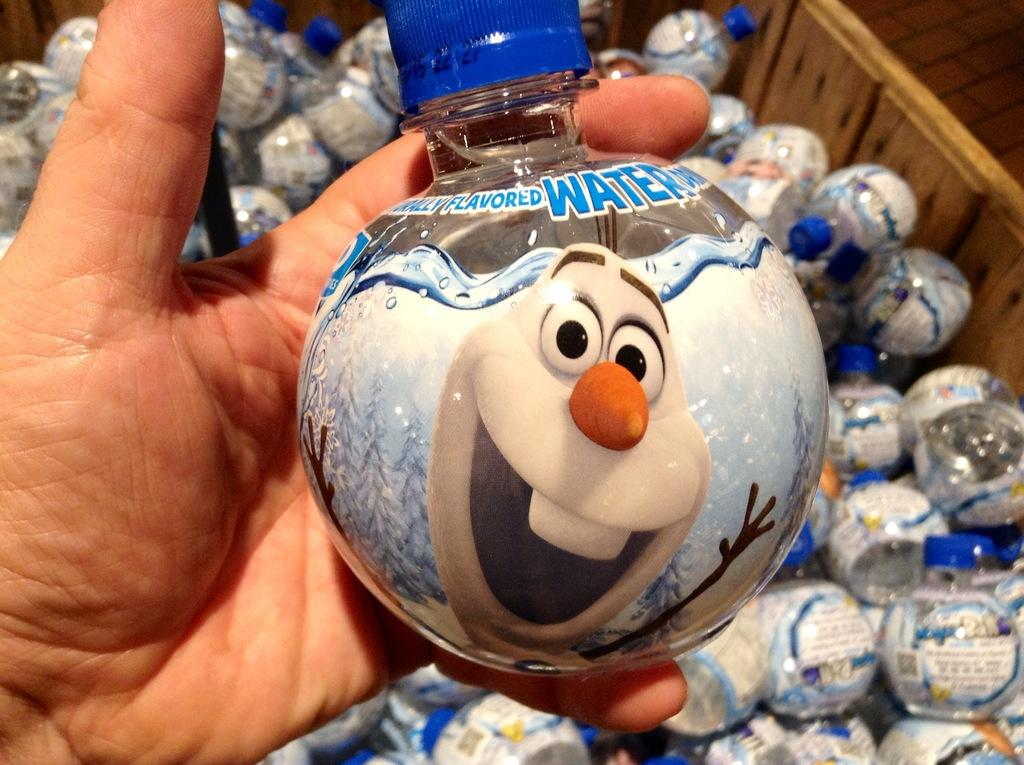What objects can be seen in the image related to hydration? There are water bottles in the image. Can you describe any human presence in the image? The hand of a person is visible in the image. What type of jeans is the person wearing in the image? There is no information about jeans or any clothing in the image; only the hand of a person is visible. 